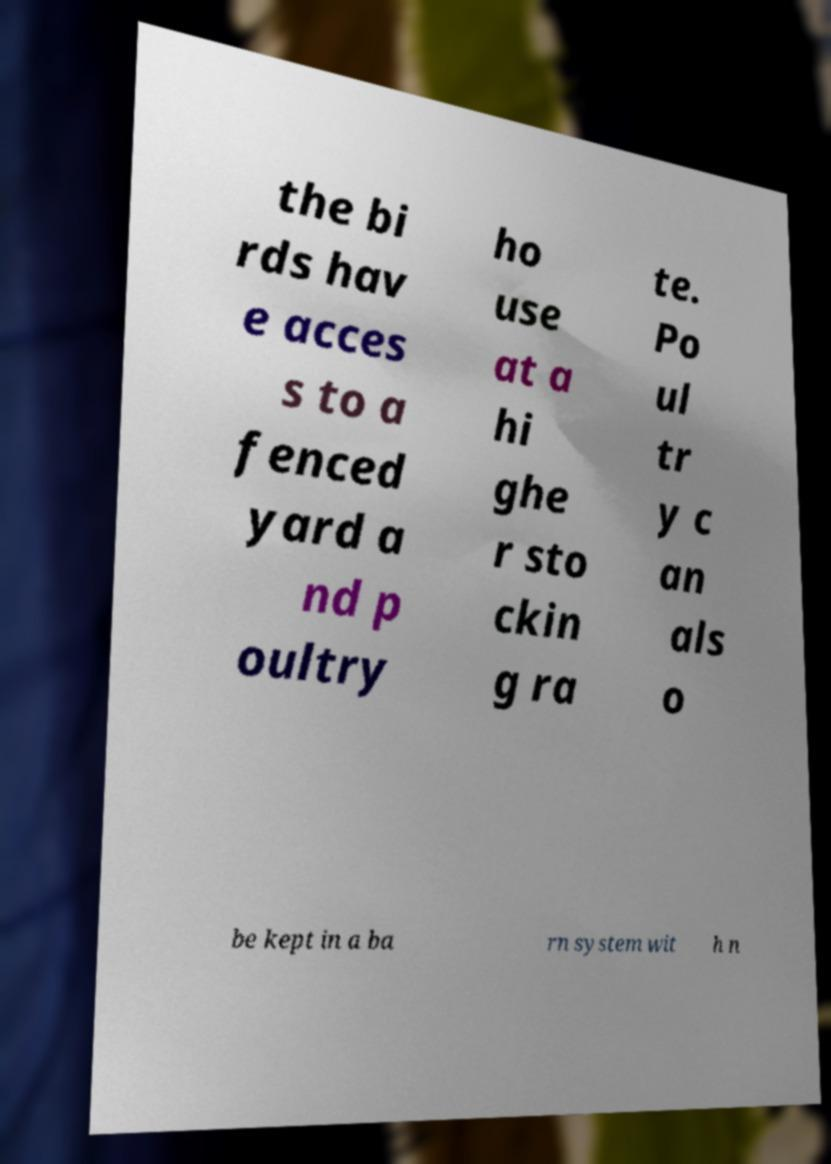Could you extract and type out the text from this image? the bi rds hav e acces s to a fenced yard a nd p oultry ho use at a hi ghe r sto ckin g ra te. Po ul tr y c an als o be kept in a ba rn system wit h n 